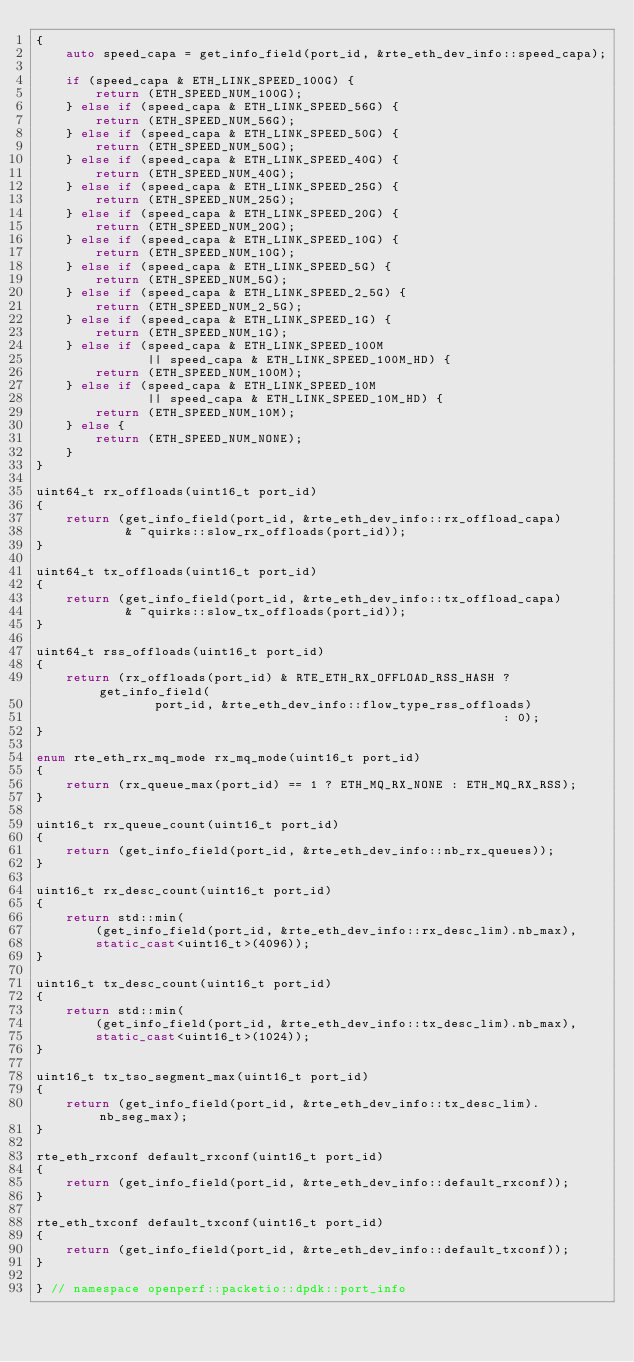Convert code to text. <code><loc_0><loc_0><loc_500><loc_500><_C++_>{
    auto speed_capa = get_info_field(port_id, &rte_eth_dev_info::speed_capa);

    if (speed_capa & ETH_LINK_SPEED_100G) {
        return (ETH_SPEED_NUM_100G);
    } else if (speed_capa & ETH_LINK_SPEED_56G) {
        return (ETH_SPEED_NUM_56G);
    } else if (speed_capa & ETH_LINK_SPEED_50G) {
        return (ETH_SPEED_NUM_50G);
    } else if (speed_capa & ETH_LINK_SPEED_40G) {
        return (ETH_SPEED_NUM_40G);
    } else if (speed_capa & ETH_LINK_SPEED_25G) {
        return (ETH_SPEED_NUM_25G);
    } else if (speed_capa & ETH_LINK_SPEED_20G) {
        return (ETH_SPEED_NUM_20G);
    } else if (speed_capa & ETH_LINK_SPEED_10G) {
        return (ETH_SPEED_NUM_10G);
    } else if (speed_capa & ETH_LINK_SPEED_5G) {
        return (ETH_SPEED_NUM_5G);
    } else if (speed_capa & ETH_LINK_SPEED_2_5G) {
        return (ETH_SPEED_NUM_2_5G);
    } else if (speed_capa & ETH_LINK_SPEED_1G) {
        return (ETH_SPEED_NUM_1G);
    } else if (speed_capa & ETH_LINK_SPEED_100M
               || speed_capa & ETH_LINK_SPEED_100M_HD) {
        return (ETH_SPEED_NUM_100M);
    } else if (speed_capa & ETH_LINK_SPEED_10M
               || speed_capa & ETH_LINK_SPEED_10M_HD) {
        return (ETH_SPEED_NUM_10M);
    } else {
        return (ETH_SPEED_NUM_NONE);
    }
}

uint64_t rx_offloads(uint16_t port_id)
{
    return (get_info_field(port_id, &rte_eth_dev_info::rx_offload_capa)
            & ~quirks::slow_rx_offloads(port_id));
}

uint64_t tx_offloads(uint16_t port_id)
{
    return (get_info_field(port_id, &rte_eth_dev_info::tx_offload_capa)
            & ~quirks::slow_tx_offloads(port_id));
}

uint64_t rss_offloads(uint16_t port_id)
{
    return (rx_offloads(port_id) & RTE_ETH_RX_OFFLOAD_RSS_HASH ? get_info_field(
                port_id, &rte_eth_dev_info::flow_type_rss_offloads)
                                                               : 0);
}

enum rte_eth_rx_mq_mode rx_mq_mode(uint16_t port_id)
{
    return (rx_queue_max(port_id) == 1 ? ETH_MQ_RX_NONE : ETH_MQ_RX_RSS);
}

uint16_t rx_queue_count(uint16_t port_id)
{
    return (get_info_field(port_id, &rte_eth_dev_info::nb_rx_queues));
}

uint16_t rx_desc_count(uint16_t port_id)
{
    return std::min(
        (get_info_field(port_id, &rte_eth_dev_info::rx_desc_lim).nb_max),
        static_cast<uint16_t>(4096));
}

uint16_t tx_desc_count(uint16_t port_id)
{
    return std::min(
        (get_info_field(port_id, &rte_eth_dev_info::tx_desc_lim).nb_max),
        static_cast<uint16_t>(1024));
}

uint16_t tx_tso_segment_max(uint16_t port_id)
{
    return (get_info_field(port_id, &rte_eth_dev_info::tx_desc_lim).nb_seg_max);
}

rte_eth_rxconf default_rxconf(uint16_t port_id)
{
    return (get_info_field(port_id, &rte_eth_dev_info::default_rxconf));
}

rte_eth_txconf default_txconf(uint16_t port_id)
{
    return (get_info_field(port_id, &rte_eth_dev_info::default_txconf));
}

} // namespace openperf::packetio::dpdk::port_info
</code> 